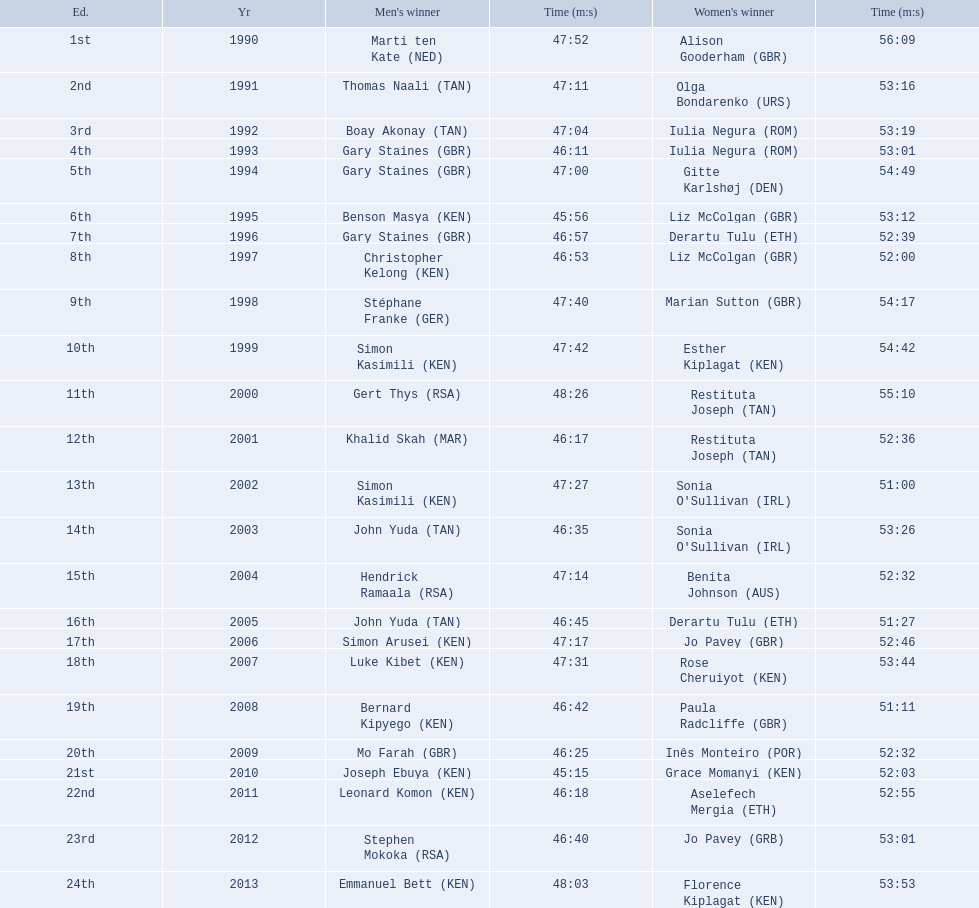Which of the runner in the great south run were women? Alison Gooderham (GBR), Olga Bondarenko (URS), Iulia Negura (ROM), Iulia Negura (ROM), Gitte Karlshøj (DEN), Liz McColgan (GBR), Derartu Tulu (ETH), Liz McColgan (GBR), Marian Sutton (GBR), Esther Kiplagat (KEN), Restituta Joseph (TAN), Restituta Joseph (TAN), Sonia O'Sullivan (IRL), Sonia O'Sullivan (IRL), Benita Johnson (AUS), Derartu Tulu (ETH), Jo Pavey (GBR), Rose Cheruiyot (KEN), Paula Radcliffe (GBR), Inês Monteiro (POR), Grace Momanyi (KEN), Aselefech Mergia (ETH), Jo Pavey (GRB), Florence Kiplagat (KEN). Of those women, which ones had a time of at least 53 minutes? Alison Gooderham (GBR), Olga Bondarenko (URS), Iulia Negura (ROM), Iulia Negura (ROM), Gitte Karlshøj (DEN), Liz McColgan (GBR), Marian Sutton (GBR), Esther Kiplagat (KEN), Restituta Joseph (TAN), Sonia O'Sullivan (IRL), Rose Cheruiyot (KEN), Jo Pavey (GRB), Florence Kiplagat (KEN). Between those women, which ones did not go over 53 minutes? Olga Bondarenko (URS), Iulia Negura (ROM), Iulia Negura (ROM), Liz McColgan (GBR), Sonia O'Sullivan (IRL), Rose Cheruiyot (KEN), Jo Pavey (GRB), Florence Kiplagat (KEN). Of those 8, what were the three slowest times? Sonia O'Sullivan (IRL), Rose Cheruiyot (KEN), Florence Kiplagat (KEN). Between only those 3 women, which runner had the fastest time? Sonia O'Sullivan (IRL). What was this women's time? 53:26. 